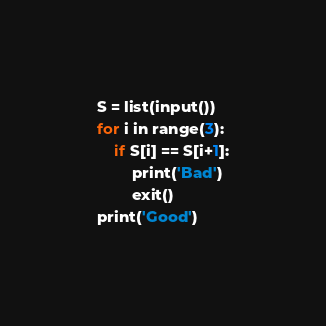<code> <loc_0><loc_0><loc_500><loc_500><_Python_>S = list(input())
for i in range(3):
    if S[i] == S[i+1]:
        print('Bad')
        exit()
print('Good')</code> 